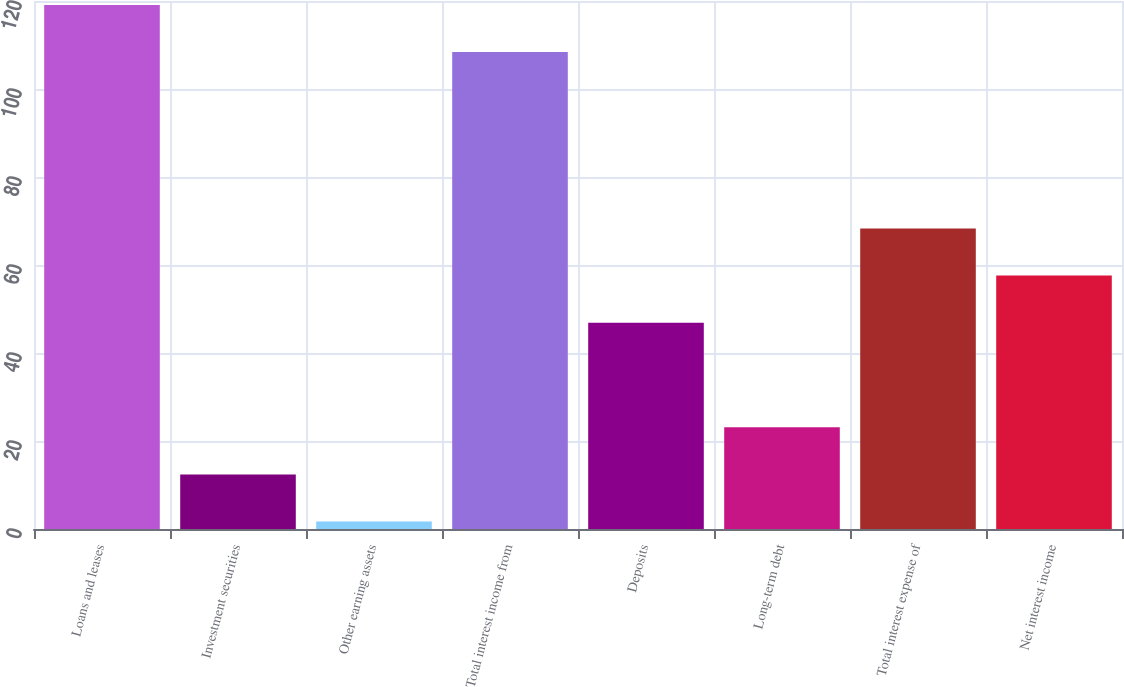Convert chart to OTSL. <chart><loc_0><loc_0><loc_500><loc_500><bar_chart><fcel>Loans and leases<fcel>Investment securities<fcel>Other earning assets<fcel>Total interest income from<fcel>Deposits<fcel>Long-term debt<fcel>Total interest expense of<fcel>Net interest income<nl><fcel>119.1<fcel>12.4<fcel>1.7<fcel>108.4<fcel>46.9<fcel>23.1<fcel>68.3<fcel>57.6<nl></chart> 